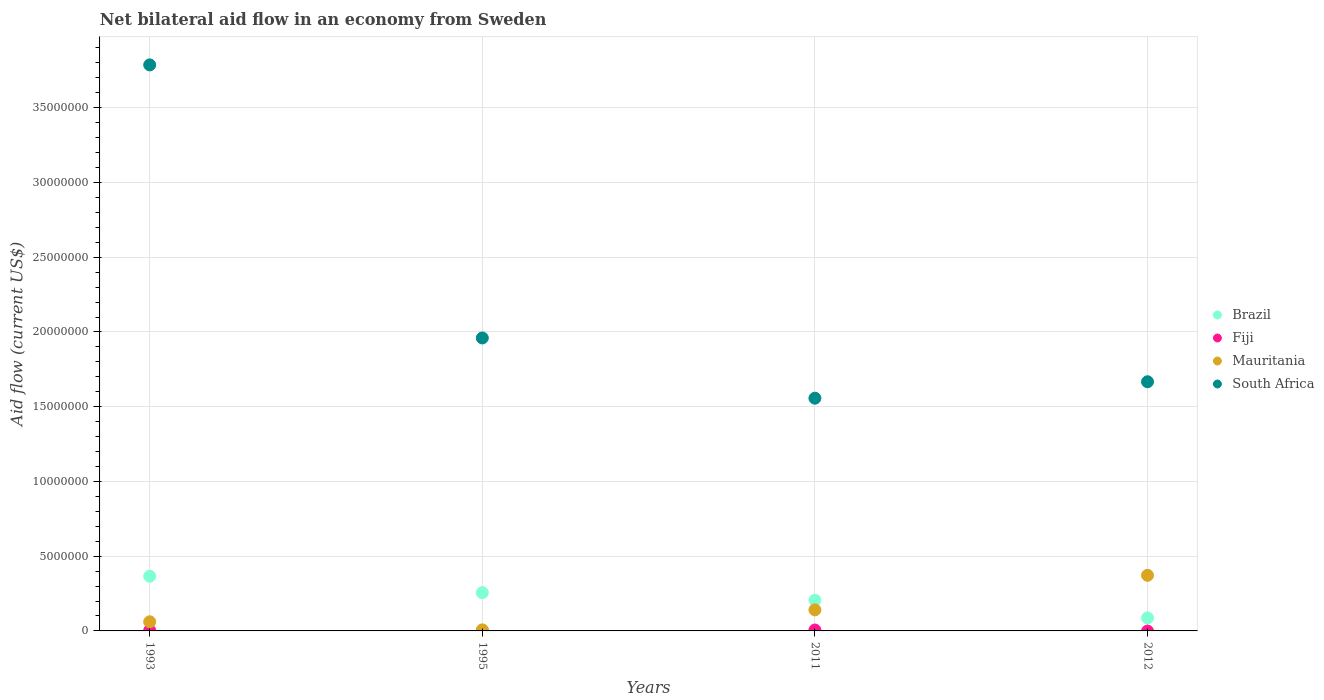Is the number of dotlines equal to the number of legend labels?
Give a very brief answer. No. What is the net bilateral aid flow in Mauritania in 2011?
Offer a terse response. 1.41e+06. Across all years, what is the maximum net bilateral aid flow in Mauritania?
Offer a very short reply. 3.72e+06. Across all years, what is the minimum net bilateral aid flow in Mauritania?
Keep it short and to the point. 7.00e+04. In which year was the net bilateral aid flow in Fiji maximum?
Keep it short and to the point. 2011. What is the total net bilateral aid flow in Mauritania in the graph?
Make the answer very short. 5.81e+06. What is the difference between the net bilateral aid flow in Brazil in 1993 and that in 2011?
Provide a succinct answer. 1.61e+06. What is the difference between the net bilateral aid flow in Brazil in 1993 and the net bilateral aid flow in Mauritania in 2011?
Make the answer very short. 2.25e+06. What is the average net bilateral aid flow in Mauritania per year?
Provide a succinct answer. 1.45e+06. In the year 1995, what is the difference between the net bilateral aid flow in South Africa and net bilateral aid flow in Fiji?
Your answer should be compact. 1.96e+07. What is the ratio of the net bilateral aid flow in South Africa in 1993 to that in 2012?
Ensure brevity in your answer.  2.27. Is the net bilateral aid flow in Brazil in 1993 less than that in 1995?
Offer a terse response. No. What is the difference between the highest and the second highest net bilateral aid flow in South Africa?
Provide a short and direct response. 1.83e+07. What is the difference between the highest and the lowest net bilateral aid flow in Mauritania?
Give a very brief answer. 3.65e+06. Is the sum of the net bilateral aid flow in South Africa in 1995 and 2012 greater than the maximum net bilateral aid flow in Brazil across all years?
Provide a short and direct response. Yes. Is it the case that in every year, the sum of the net bilateral aid flow in South Africa and net bilateral aid flow in Brazil  is greater than the net bilateral aid flow in Mauritania?
Your answer should be compact. Yes. Does the net bilateral aid flow in South Africa monotonically increase over the years?
Provide a short and direct response. No. Is the net bilateral aid flow in Fiji strictly less than the net bilateral aid flow in South Africa over the years?
Provide a succinct answer. Yes. How many years are there in the graph?
Make the answer very short. 4. What is the difference between two consecutive major ticks on the Y-axis?
Keep it short and to the point. 5.00e+06. Does the graph contain any zero values?
Your answer should be compact. Yes. Does the graph contain grids?
Ensure brevity in your answer.  Yes. Where does the legend appear in the graph?
Make the answer very short. Center right. How many legend labels are there?
Provide a succinct answer. 4. How are the legend labels stacked?
Your response must be concise. Vertical. What is the title of the graph?
Your answer should be very brief. Net bilateral aid flow in an economy from Sweden. What is the label or title of the X-axis?
Give a very brief answer. Years. What is the label or title of the Y-axis?
Give a very brief answer. Aid flow (current US$). What is the Aid flow (current US$) of Brazil in 1993?
Provide a short and direct response. 3.66e+06. What is the Aid flow (current US$) in South Africa in 1993?
Your answer should be compact. 3.79e+07. What is the Aid flow (current US$) of Brazil in 1995?
Your answer should be very brief. 2.56e+06. What is the Aid flow (current US$) of South Africa in 1995?
Make the answer very short. 1.96e+07. What is the Aid flow (current US$) of Brazil in 2011?
Provide a succinct answer. 2.05e+06. What is the Aid flow (current US$) of Mauritania in 2011?
Your response must be concise. 1.41e+06. What is the Aid flow (current US$) in South Africa in 2011?
Your answer should be compact. 1.56e+07. What is the Aid flow (current US$) of Brazil in 2012?
Your response must be concise. 8.70e+05. What is the Aid flow (current US$) in Fiji in 2012?
Offer a very short reply. 0. What is the Aid flow (current US$) in Mauritania in 2012?
Make the answer very short. 3.72e+06. What is the Aid flow (current US$) of South Africa in 2012?
Keep it short and to the point. 1.67e+07. Across all years, what is the maximum Aid flow (current US$) of Brazil?
Make the answer very short. 3.66e+06. Across all years, what is the maximum Aid flow (current US$) in Mauritania?
Provide a succinct answer. 3.72e+06. Across all years, what is the maximum Aid flow (current US$) of South Africa?
Offer a terse response. 3.79e+07. Across all years, what is the minimum Aid flow (current US$) of Brazil?
Provide a succinct answer. 8.70e+05. Across all years, what is the minimum Aid flow (current US$) in Mauritania?
Ensure brevity in your answer.  7.00e+04. Across all years, what is the minimum Aid flow (current US$) in South Africa?
Your answer should be compact. 1.56e+07. What is the total Aid flow (current US$) of Brazil in the graph?
Make the answer very short. 9.14e+06. What is the total Aid flow (current US$) of Fiji in the graph?
Offer a very short reply. 1.00e+05. What is the total Aid flow (current US$) of Mauritania in the graph?
Your answer should be very brief. 5.81e+06. What is the total Aid flow (current US$) of South Africa in the graph?
Give a very brief answer. 8.97e+07. What is the difference between the Aid flow (current US$) in Brazil in 1993 and that in 1995?
Keep it short and to the point. 1.10e+06. What is the difference between the Aid flow (current US$) in Mauritania in 1993 and that in 1995?
Make the answer very short. 5.40e+05. What is the difference between the Aid flow (current US$) in South Africa in 1993 and that in 1995?
Keep it short and to the point. 1.83e+07. What is the difference between the Aid flow (current US$) in Brazil in 1993 and that in 2011?
Ensure brevity in your answer.  1.61e+06. What is the difference between the Aid flow (current US$) in Fiji in 1993 and that in 2011?
Offer a very short reply. -3.00e+04. What is the difference between the Aid flow (current US$) of Mauritania in 1993 and that in 2011?
Keep it short and to the point. -8.00e+05. What is the difference between the Aid flow (current US$) of South Africa in 1993 and that in 2011?
Make the answer very short. 2.23e+07. What is the difference between the Aid flow (current US$) of Brazil in 1993 and that in 2012?
Offer a terse response. 2.79e+06. What is the difference between the Aid flow (current US$) of Mauritania in 1993 and that in 2012?
Provide a succinct answer. -3.11e+06. What is the difference between the Aid flow (current US$) of South Africa in 1993 and that in 2012?
Provide a short and direct response. 2.12e+07. What is the difference between the Aid flow (current US$) of Brazil in 1995 and that in 2011?
Your response must be concise. 5.10e+05. What is the difference between the Aid flow (current US$) in Fiji in 1995 and that in 2011?
Offer a terse response. -5.00e+04. What is the difference between the Aid flow (current US$) of Mauritania in 1995 and that in 2011?
Offer a terse response. -1.34e+06. What is the difference between the Aid flow (current US$) in South Africa in 1995 and that in 2011?
Provide a short and direct response. 4.03e+06. What is the difference between the Aid flow (current US$) in Brazil in 1995 and that in 2012?
Your answer should be compact. 1.69e+06. What is the difference between the Aid flow (current US$) in Mauritania in 1995 and that in 2012?
Your answer should be very brief. -3.65e+06. What is the difference between the Aid flow (current US$) of South Africa in 1995 and that in 2012?
Your response must be concise. 2.93e+06. What is the difference between the Aid flow (current US$) in Brazil in 2011 and that in 2012?
Offer a very short reply. 1.18e+06. What is the difference between the Aid flow (current US$) of Mauritania in 2011 and that in 2012?
Provide a succinct answer. -2.31e+06. What is the difference between the Aid flow (current US$) in South Africa in 2011 and that in 2012?
Keep it short and to the point. -1.10e+06. What is the difference between the Aid flow (current US$) of Brazil in 1993 and the Aid flow (current US$) of Fiji in 1995?
Provide a short and direct response. 3.65e+06. What is the difference between the Aid flow (current US$) of Brazil in 1993 and the Aid flow (current US$) of Mauritania in 1995?
Provide a short and direct response. 3.59e+06. What is the difference between the Aid flow (current US$) of Brazil in 1993 and the Aid flow (current US$) of South Africa in 1995?
Offer a terse response. -1.59e+07. What is the difference between the Aid flow (current US$) in Fiji in 1993 and the Aid flow (current US$) in South Africa in 1995?
Your answer should be very brief. -1.96e+07. What is the difference between the Aid flow (current US$) of Mauritania in 1993 and the Aid flow (current US$) of South Africa in 1995?
Provide a succinct answer. -1.90e+07. What is the difference between the Aid flow (current US$) of Brazil in 1993 and the Aid flow (current US$) of Fiji in 2011?
Ensure brevity in your answer.  3.60e+06. What is the difference between the Aid flow (current US$) of Brazil in 1993 and the Aid flow (current US$) of Mauritania in 2011?
Provide a short and direct response. 2.25e+06. What is the difference between the Aid flow (current US$) in Brazil in 1993 and the Aid flow (current US$) in South Africa in 2011?
Your answer should be very brief. -1.19e+07. What is the difference between the Aid flow (current US$) of Fiji in 1993 and the Aid flow (current US$) of Mauritania in 2011?
Your answer should be compact. -1.38e+06. What is the difference between the Aid flow (current US$) of Fiji in 1993 and the Aid flow (current US$) of South Africa in 2011?
Ensure brevity in your answer.  -1.55e+07. What is the difference between the Aid flow (current US$) of Mauritania in 1993 and the Aid flow (current US$) of South Africa in 2011?
Your response must be concise. -1.50e+07. What is the difference between the Aid flow (current US$) of Brazil in 1993 and the Aid flow (current US$) of Mauritania in 2012?
Your answer should be compact. -6.00e+04. What is the difference between the Aid flow (current US$) in Brazil in 1993 and the Aid flow (current US$) in South Africa in 2012?
Your answer should be very brief. -1.30e+07. What is the difference between the Aid flow (current US$) of Fiji in 1993 and the Aid flow (current US$) of Mauritania in 2012?
Provide a succinct answer. -3.69e+06. What is the difference between the Aid flow (current US$) of Fiji in 1993 and the Aid flow (current US$) of South Africa in 2012?
Provide a succinct answer. -1.66e+07. What is the difference between the Aid flow (current US$) of Mauritania in 1993 and the Aid flow (current US$) of South Africa in 2012?
Your response must be concise. -1.61e+07. What is the difference between the Aid flow (current US$) of Brazil in 1995 and the Aid flow (current US$) of Fiji in 2011?
Provide a succinct answer. 2.50e+06. What is the difference between the Aid flow (current US$) of Brazil in 1995 and the Aid flow (current US$) of Mauritania in 2011?
Your response must be concise. 1.15e+06. What is the difference between the Aid flow (current US$) of Brazil in 1995 and the Aid flow (current US$) of South Africa in 2011?
Your response must be concise. -1.30e+07. What is the difference between the Aid flow (current US$) of Fiji in 1995 and the Aid flow (current US$) of Mauritania in 2011?
Offer a very short reply. -1.40e+06. What is the difference between the Aid flow (current US$) in Fiji in 1995 and the Aid flow (current US$) in South Africa in 2011?
Make the answer very short. -1.56e+07. What is the difference between the Aid flow (current US$) of Mauritania in 1995 and the Aid flow (current US$) of South Africa in 2011?
Offer a terse response. -1.55e+07. What is the difference between the Aid flow (current US$) in Brazil in 1995 and the Aid flow (current US$) in Mauritania in 2012?
Provide a short and direct response. -1.16e+06. What is the difference between the Aid flow (current US$) in Brazil in 1995 and the Aid flow (current US$) in South Africa in 2012?
Make the answer very short. -1.41e+07. What is the difference between the Aid flow (current US$) of Fiji in 1995 and the Aid flow (current US$) of Mauritania in 2012?
Ensure brevity in your answer.  -3.71e+06. What is the difference between the Aid flow (current US$) of Fiji in 1995 and the Aid flow (current US$) of South Africa in 2012?
Provide a short and direct response. -1.67e+07. What is the difference between the Aid flow (current US$) of Mauritania in 1995 and the Aid flow (current US$) of South Africa in 2012?
Give a very brief answer. -1.66e+07. What is the difference between the Aid flow (current US$) of Brazil in 2011 and the Aid flow (current US$) of Mauritania in 2012?
Offer a very short reply. -1.67e+06. What is the difference between the Aid flow (current US$) in Brazil in 2011 and the Aid flow (current US$) in South Africa in 2012?
Make the answer very short. -1.46e+07. What is the difference between the Aid flow (current US$) of Fiji in 2011 and the Aid flow (current US$) of Mauritania in 2012?
Make the answer very short. -3.66e+06. What is the difference between the Aid flow (current US$) in Fiji in 2011 and the Aid flow (current US$) in South Africa in 2012?
Provide a succinct answer. -1.66e+07. What is the difference between the Aid flow (current US$) of Mauritania in 2011 and the Aid flow (current US$) of South Africa in 2012?
Your response must be concise. -1.53e+07. What is the average Aid flow (current US$) in Brazil per year?
Give a very brief answer. 2.28e+06. What is the average Aid flow (current US$) in Fiji per year?
Your answer should be compact. 2.50e+04. What is the average Aid flow (current US$) of Mauritania per year?
Offer a terse response. 1.45e+06. What is the average Aid flow (current US$) of South Africa per year?
Your answer should be very brief. 2.24e+07. In the year 1993, what is the difference between the Aid flow (current US$) in Brazil and Aid flow (current US$) in Fiji?
Keep it short and to the point. 3.63e+06. In the year 1993, what is the difference between the Aid flow (current US$) in Brazil and Aid flow (current US$) in Mauritania?
Ensure brevity in your answer.  3.05e+06. In the year 1993, what is the difference between the Aid flow (current US$) in Brazil and Aid flow (current US$) in South Africa?
Keep it short and to the point. -3.42e+07. In the year 1993, what is the difference between the Aid flow (current US$) of Fiji and Aid flow (current US$) of Mauritania?
Keep it short and to the point. -5.80e+05. In the year 1993, what is the difference between the Aid flow (current US$) in Fiji and Aid flow (current US$) in South Africa?
Ensure brevity in your answer.  -3.78e+07. In the year 1993, what is the difference between the Aid flow (current US$) in Mauritania and Aid flow (current US$) in South Africa?
Give a very brief answer. -3.73e+07. In the year 1995, what is the difference between the Aid flow (current US$) in Brazil and Aid flow (current US$) in Fiji?
Ensure brevity in your answer.  2.55e+06. In the year 1995, what is the difference between the Aid flow (current US$) of Brazil and Aid flow (current US$) of Mauritania?
Your answer should be compact. 2.49e+06. In the year 1995, what is the difference between the Aid flow (current US$) in Brazil and Aid flow (current US$) in South Africa?
Ensure brevity in your answer.  -1.70e+07. In the year 1995, what is the difference between the Aid flow (current US$) in Fiji and Aid flow (current US$) in Mauritania?
Your answer should be compact. -6.00e+04. In the year 1995, what is the difference between the Aid flow (current US$) of Fiji and Aid flow (current US$) of South Africa?
Your answer should be compact. -1.96e+07. In the year 1995, what is the difference between the Aid flow (current US$) in Mauritania and Aid flow (current US$) in South Africa?
Ensure brevity in your answer.  -1.95e+07. In the year 2011, what is the difference between the Aid flow (current US$) in Brazil and Aid flow (current US$) in Fiji?
Your answer should be very brief. 1.99e+06. In the year 2011, what is the difference between the Aid flow (current US$) in Brazil and Aid flow (current US$) in Mauritania?
Your response must be concise. 6.40e+05. In the year 2011, what is the difference between the Aid flow (current US$) in Brazil and Aid flow (current US$) in South Africa?
Your answer should be compact. -1.35e+07. In the year 2011, what is the difference between the Aid flow (current US$) of Fiji and Aid flow (current US$) of Mauritania?
Your answer should be very brief. -1.35e+06. In the year 2011, what is the difference between the Aid flow (current US$) in Fiji and Aid flow (current US$) in South Africa?
Give a very brief answer. -1.55e+07. In the year 2011, what is the difference between the Aid flow (current US$) in Mauritania and Aid flow (current US$) in South Africa?
Your response must be concise. -1.42e+07. In the year 2012, what is the difference between the Aid flow (current US$) in Brazil and Aid flow (current US$) in Mauritania?
Ensure brevity in your answer.  -2.85e+06. In the year 2012, what is the difference between the Aid flow (current US$) in Brazil and Aid flow (current US$) in South Africa?
Give a very brief answer. -1.58e+07. In the year 2012, what is the difference between the Aid flow (current US$) of Mauritania and Aid flow (current US$) of South Africa?
Keep it short and to the point. -1.30e+07. What is the ratio of the Aid flow (current US$) in Brazil in 1993 to that in 1995?
Your answer should be compact. 1.43. What is the ratio of the Aid flow (current US$) of Mauritania in 1993 to that in 1995?
Provide a succinct answer. 8.71. What is the ratio of the Aid flow (current US$) of South Africa in 1993 to that in 1995?
Provide a short and direct response. 1.93. What is the ratio of the Aid flow (current US$) of Brazil in 1993 to that in 2011?
Provide a short and direct response. 1.79. What is the ratio of the Aid flow (current US$) of Mauritania in 1993 to that in 2011?
Keep it short and to the point. 0.43. What is the ratio of the Aid flow (current US$) in South Africa in 1993 to that in 2011?
Give a very brief answer. 2.43. What is the ratio of the Aid flow (current US$) in Brazil in 1993 to that in 2012?
Ensure brevity in your answer.  4.21. What is the ratio of the Aid flow (current US$) of Mauritania in 1993 to that in 2012?
Offer a very short reply. 0.16. What is the ratio of the Aid flow (current US$) in South Africa in 1993 to that in 2012?
Make the answer very short. 2.27. What is the ratio of the Aid flow (current US$) in Brazil in 1995 to that in 2011?
Make the answer very short. 1.25. What is the ratio of the Aid flow (current US$) of Fiji in 1995 to that in 2011?
Offer a very short reply. 0.17. What is the ratio of the Aid flow (current US$) of Mauritania in 1995 to that in 2011?
Offer a very short reply. 0.05. What is the ratio of the Aid flow (current US$) in South Africa in 1995 to that in 2011?
Offer a terse response. 1.26. What is the ratio of the Aid flow (current US$) of Brazil in 1995 to that in 2012?
Give a very brief answer. 2.94. What is the ratio of the Aid flow (current US$) of Mauritania in 1995 to that in 2012?
Give a very brief answer. 0.02. What is the ratio of the Aid flow (current US$) of South Africa in 1995 to that in 2012?
Offer a very short reply. 1.18. What is the ratio of the Aid flow (current US$) of Brazil in 2011 to that in 2012?
Ensure brevity in your answer.  2.36. What is the ratio of the Aid flow (current US$) of Mauritania in 2011 to that in 2012?
Offer a terse response. 0.38. What is the ratio of the Aid flow (current US$) in South Africa in 2011 to that in 2012?
Offer a terse response. 0.93. What is the difference between the highest and the second highest Aid flow (current US$) of Brazil?
Keep it short and to the point. 1.10e+06. What is the difference between the highest and the second highest Aid flow (current US$) in Mauritania?
Offer a terse response. 2.31e+06. What is the difference between the highest and the second highest Aid flow (current US$) in South Africa?
Ensure brevity in your answer.  1.83e+07. What is the difference between the highest and the lowest Aid flow (current US$) in Brazil?
Your answer should be very brief. 2.79e+06. What is the difference between the highest and the lowest Aid flow (current US$) in Fiji?
Make the answer very short. 6.00e+04. What is the difference between the highest and the lowest Aid flow (current US$) of Mauritania?
Ensure brevity in your answer.  3.65e+06. What is the difference between the highest and the lowest Aid flow (current US$) in South Africa?
Give a very brief answer. 2.23e+07. 